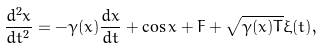<formula> <loc_0><loc_0><loc_500><loc_500>\frac { d ^ { 2 } x } { d t ^ { 2 } } = - \gamma ( x ) \frac { d x } { d t } + \cos x + F + \sqrt { \gamma ( x ) T } \xi ( t ) ,</formula> 